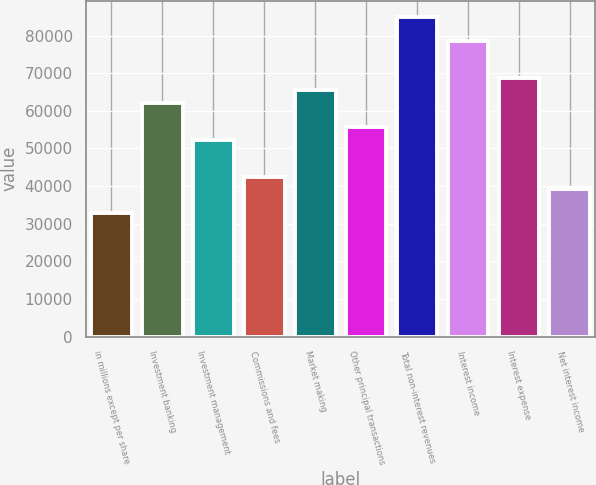Convert chart to OTSL. <chart><loc_0><loc_0><loc_500><loc_500><bar_chart><fcel>in millions except per share<fcel>Investment banking<fcel>Investment management<fcel>Commissions and fees<fcel>Market making<fcel>Other principal transactions<fcel>Total non-interest revenues<fcel>Interest income<fcel>Interest expense<fcel>Net interest income<nl><fcel>32730<fcel>62178.9<fcel>52362.6<fcel>42546.3<fcel>65451<fcel>55634.7<fcel>85083.6<fcel>78539.4<fcel>68723.1<fcel>39274.2<nl></chart> 